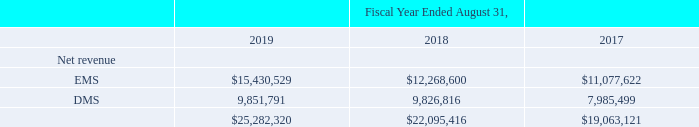Segment Data
Operating segments are defined as components of an enterprise that engage in business activities from which they may earn revenues and incur expenses; for which separate financial information is available; and whose operating results are regularly reviewed by the chief operating decision maker to assess the performance of the individual segment and make decisions about resources to be allocated to the segment.
The Company derives its revenue from providing comprehensive electronics design, production and product management services. The chief operating decision maker evaluates performance and allocates resources on a segment basis. The Company’s operating segments consist of two segments – EMS and DMS, which are also the Company’s reportable segments. The segments are organized based on the economic profiles of the services performed, including manufacturing capabilities, market strategy, margins, return on capital and risk profiles.
The EMS segment is focused around leveraging IT, supply chain design and engineering, technologies largely centered on core electronics, utilizing the Company’s large scale manufacturing infrastructure and the ability to serve a broad range of end markets. The EMS segment is a high volume business that produces products at a quicker rate (i.e. cycle time) and in larger quantities and includes customers primarily in the automotive and transportation, capital equipment, cloud, computing and storage, defense and aerospace, industrial and energy, networking and telecommunications, print and retail, and smart home and appliances industries.
The DMS segment is focused on providing engineering solutions, with an emphasis on material sciences, technologies and healthcare. The DMS segment includes customers primarily in the edge devices and accessories, healthcare, mobility and packaging industries.
Net revenue for the operating segments is attributed to the segment in which the service is performed. An operating segment’s performance is evaluated based on its pre-tax operating contribution, or segment income. Segment income is defined as net revenue less cost of revenue, segment selling, general and administrative expenses, segment research and development expenses and an allocation of corporate manufacturing expenses and selling, general and administrative expenses. Segment income does not include amortization of intangibles, stock-based compensation expense and related charges, restructuring and related charges, distressed customer charges, acquisition and integration charges, loss on disposal of subsidiaries, settlement of receivables and related charges, impairment of notes receivable and related charges, restructuring of securities loss, goodwill impairment charges, business interruption and impairment charges, net, income (loss) from discontinued operations, gain (loss) on sale of discontinued operations, other expense, interest income, interest expense, income tax expense or adjustment for net income (loss) attributable to noncontrolling interests.
Total segment assets are defined as accounts receivable, inventories, net, customer-related property, plant and equipment, intangible assets net of accumulated amortization and goodwill. All other non-segment assets are reviewed on a global basis by management. Transactions between operating segments are generally recorded at amounts that approximate those at which we would transact with third parties. 99
The following tables set forth operating segment information (in thousands):
What was the Net revenue for EMS in 2019?
Answer scale should be: thousand. $15,430,529. What was the DMS segment focused on? Providing engineering solutions, with an emphasis on material sciences, technologies and healthcare. What years does the table provide information for net revenue for EMS and DMS segments? 2019, 2018, 2017. How many years did net revenue from EMS exceed $15,000,000 thousand? 2019
Answer: 1. What was the change in the net revenue from EMS between 2018 and 2019?
Answer scale should be: thousand. 15,430,529-12,268,600
Answer: 3161929. What was the average year-on-year percentage change in total net revenue from 2017-2019?
Answer scale should be: percent. ((($25,282,320-$22,095,416)/$22,095,416)+(($22,095,416-$19,063,121)/$19,063,121))/2
Answer: 15.16. 